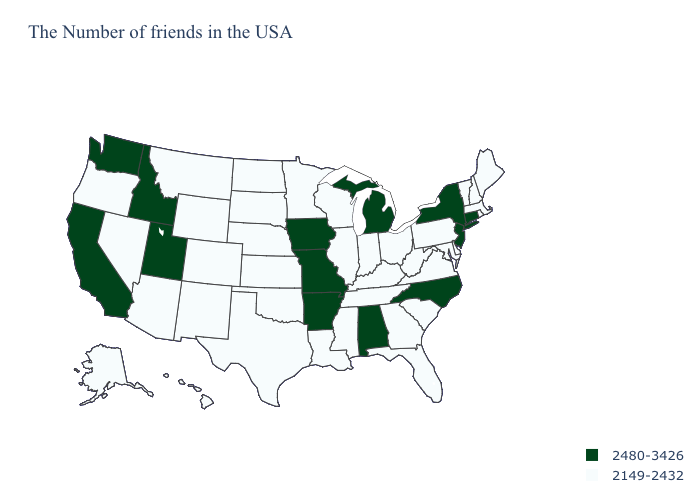What is the value of Texas?
Give a very brief answer. 2149-2432. Name the states that have a value in the range 2149-2432?
Answer briefly. Maine, Massachusetts, Rhode Island, New Hampshire, Vermont, Delaware, Maryland, Pennsylvania, Virginia, South Carolina, West Virginia, Ohio, Florida, Georgia, Kentucky, Indiana, Tennessee, Wisconsin, Illinois, Mississippi, Louisiana, Minnesota, Kansas, Nebraska, Oklahoma, Texas, South Dakota, North Dakota, Wyoming, Colorado, New Mexico, Montana, Arizona, Nevada, Oregon, Alaska, Hawaii. Name the states that have a value in the range 2149-2432?
Short answer required. Maine, Massachusetts, Rhode Island, New Hampshire, Vermont, Delaware, Maryland, Pennsylvania, Virginia, South Carolina, West Virginia, Ohio, Florida, Georgia, Kentucky, Indiana, Tennessee, Wisconsin, Illinois, Mississippi, Louisiana, Minnesota, Kansas, Nebraska, Oklahoma, Texas, South Dakota, North Dakota, Wyoming, Colorado, New Mexico, Montana, Arizona, Nevada, Oregon, Alaska, Hawaii. Does Washington have the same value as Louisiana?
Quick response, please. No. Name the states that have a value in the range 2149-2432?
Be succinct. Maine, Massachusetts, Rhode Island, New Hampshire, Vermont, Delaware, Maryland, Pennsylvania, Virginia, South Carolina, West Virginia, Ohio, Florida, Georgia, Kentucky, Indiana, Tennessee, Wisconsin, Illinois, Mississippi, Louisiana, Minnesota, Kansas, Nebraska, Oklahoma, Texas, South Dakota, North Dakota, Wyoming, Colorado, New Mexico, Montana, Arizona, Nevada, Oregon, Alaska, Hawaii. Which states have the lowest value in the South?
Short answer required. Delaware, Maryland, Virginia, South Carolina, West Virginia, Florida, Georgia, Kentucky, Tennessee, Mississippi, Louisiana, Oklahoma, Texas. Name the states that have a value in the range 2149-2432?
Short answer required. Maine, Massachusetts, Rhode Island, New Hampshire, Vermont, Delaware, Maryland, Pennsylvania, Virginia, South Carolina, West Virginia, Ohio, Florida, Georgia, Kentucky, Indiana, Tennessee, Wisconsin, Illinois, Mississippi, Louisiana, Minnesota, Kansas, Nebraska, Oklahoma, Texas, South Dakota, North Dakota, Wyoming, Colorado, New Mexico, Montana, Arizona, Nevada, Oregon, Alaska, Hawaii. What is the lowest value in the MidWest?
Concise answer only. 2149-2432. Name the states that have a value in the range 2149-2432?
Be succinct. Maine, Massachusetts, Rhode Island, New Hampshire, Vermont, Delaware, Maryland, Pennsylvania, Virginia, South Carolina, West Virginia, Ohio, Florida, Georgia, Kentucky, Indiana, Tennessee, Wisconsin, Illinois, Mississippi, Louisiana, Minnesota, Kansas, Nebraska, Oklahoma, Texas, South Dakota, North Dakota, Wyoming, Colorado, New Mexico, Montana, Arizona, Nevada, Oregon, Alaska, Hawaii. Name the states that have a value in the range 2480-3426?
Quick response, please. Connecticut, New York, New Jersey, North Carolina, Michigan, Alabama, Missouri, Arkansas, Iowa, Utah, Idaho, California, Washington. Which states have the highest value in the USA?
Answer briefly. Connecticut, New York, New Jersey, North Carolina, Michigan, Alabama, Missouri, Arkansas, Iowa, Utah, Idaho, California, Washington. Which states hav the highest value in the South?
Answer briefly. North Carolina, Alabama, Arkansas. Among the states that border Iowa , does Illinois have the lowest value?
Concise answer only. Yes. Name the states that have a value in the range 2149-2432?
Keep it brief. Maine, Massachusetts, Rhode Island, New Hampshire, Vermont, Delaware, Maryland, Pennsylvania, Virginia, South Carolina, West Virginia, Ohio, Florida, Georgia, Kentucky, Indiana, Tennessee, Wisconsin, Illinois, Mississippi, Louisiana, Minnesota, Kansas, Nebraska, Oklahoma, Texas, South Dakota, North Dakota, Wyoming, Colorado, New Mexico, Montana, Arizona, Nevada, Oregon, Alaska, Hawaii. Which states hav the highest value in the MidWest?
Keep it brief. Michigan, Missouri, Iowa. 